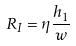Convert formula to latex. <formula><loc_0><loc_0><loc_500><loc_500>R _ { I } = \eta \frac { h _ { 1 } } { w }</formula> 